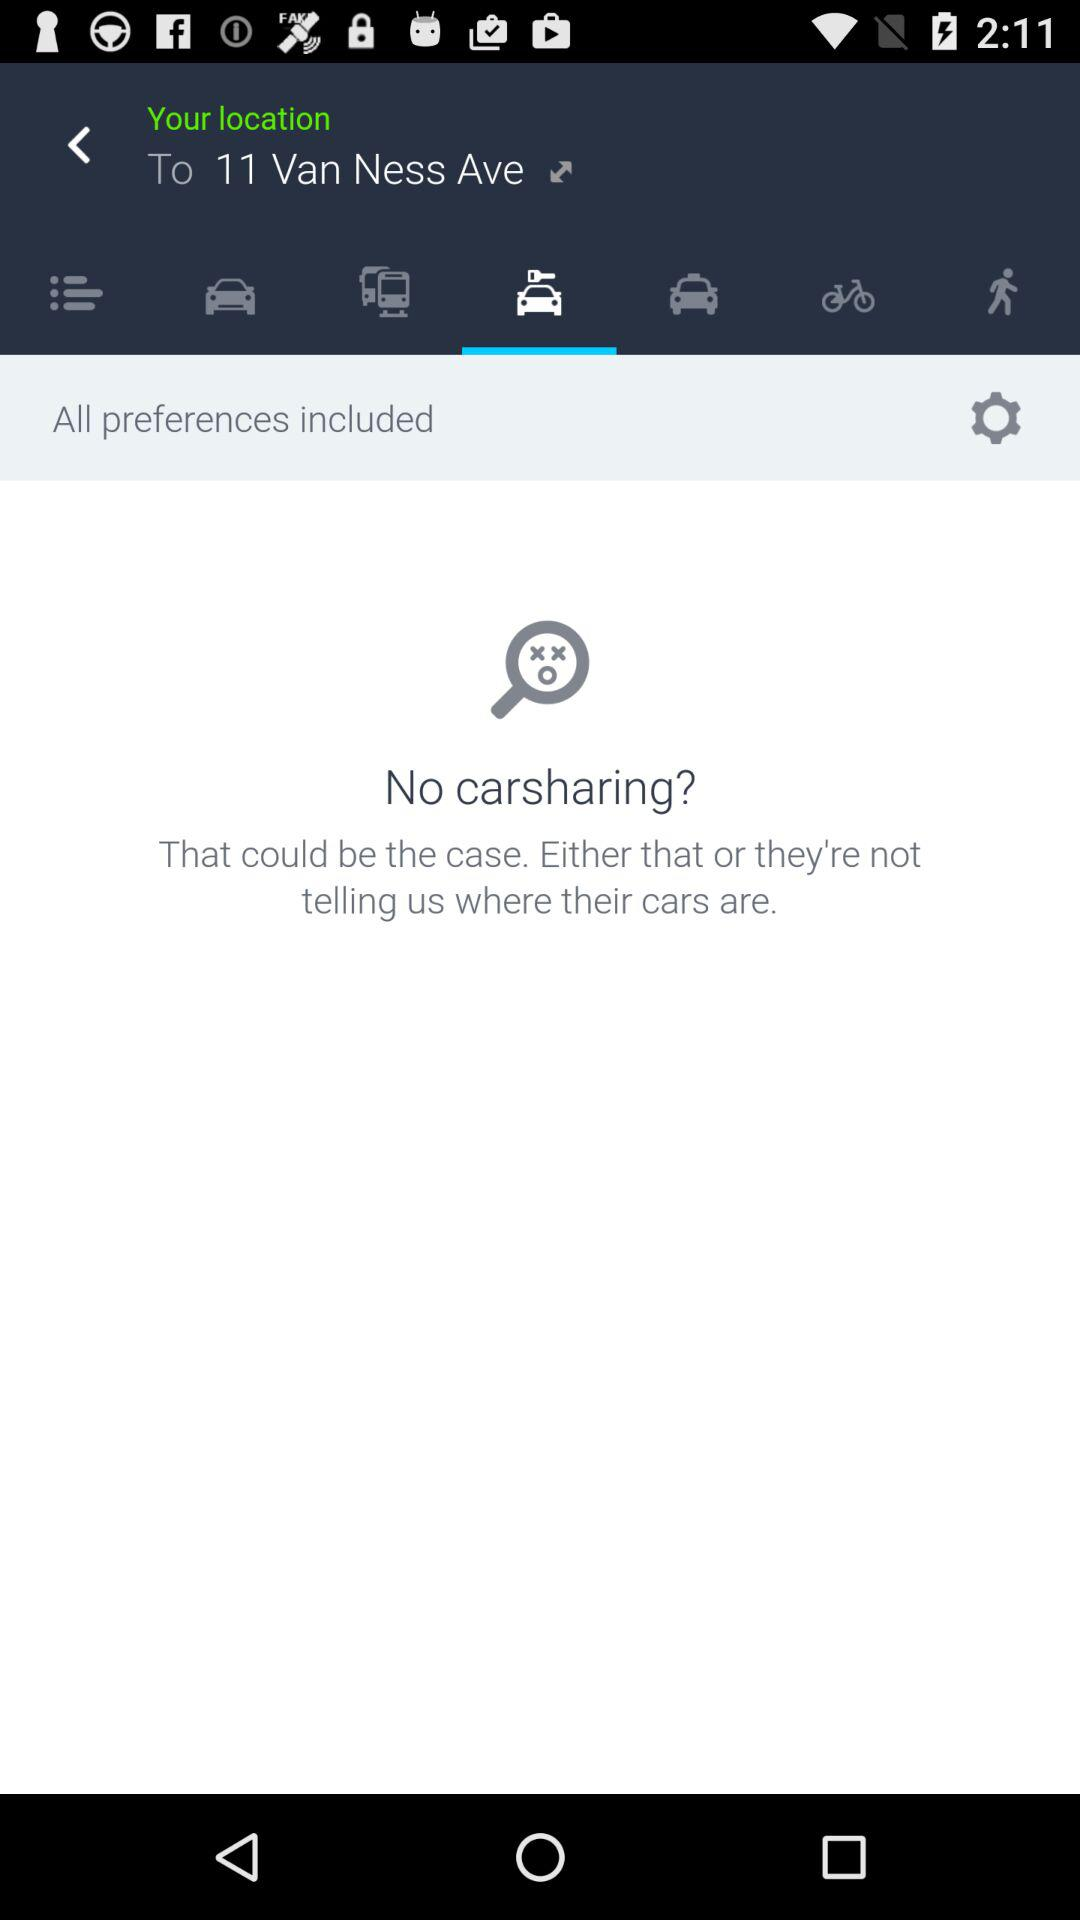What is the mentioned location? The mentioned location is 11 Van Ness Ave. 